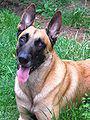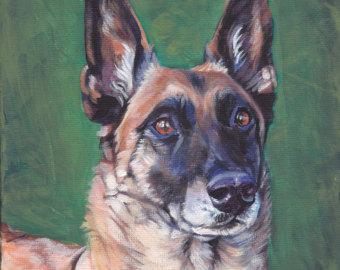The first image is the image on the left, the second image is the image on the right. Analyze the images presented: Is the assertion "The dog on the left is lying down in the grass." valid? Answer yes or no. Yes. 